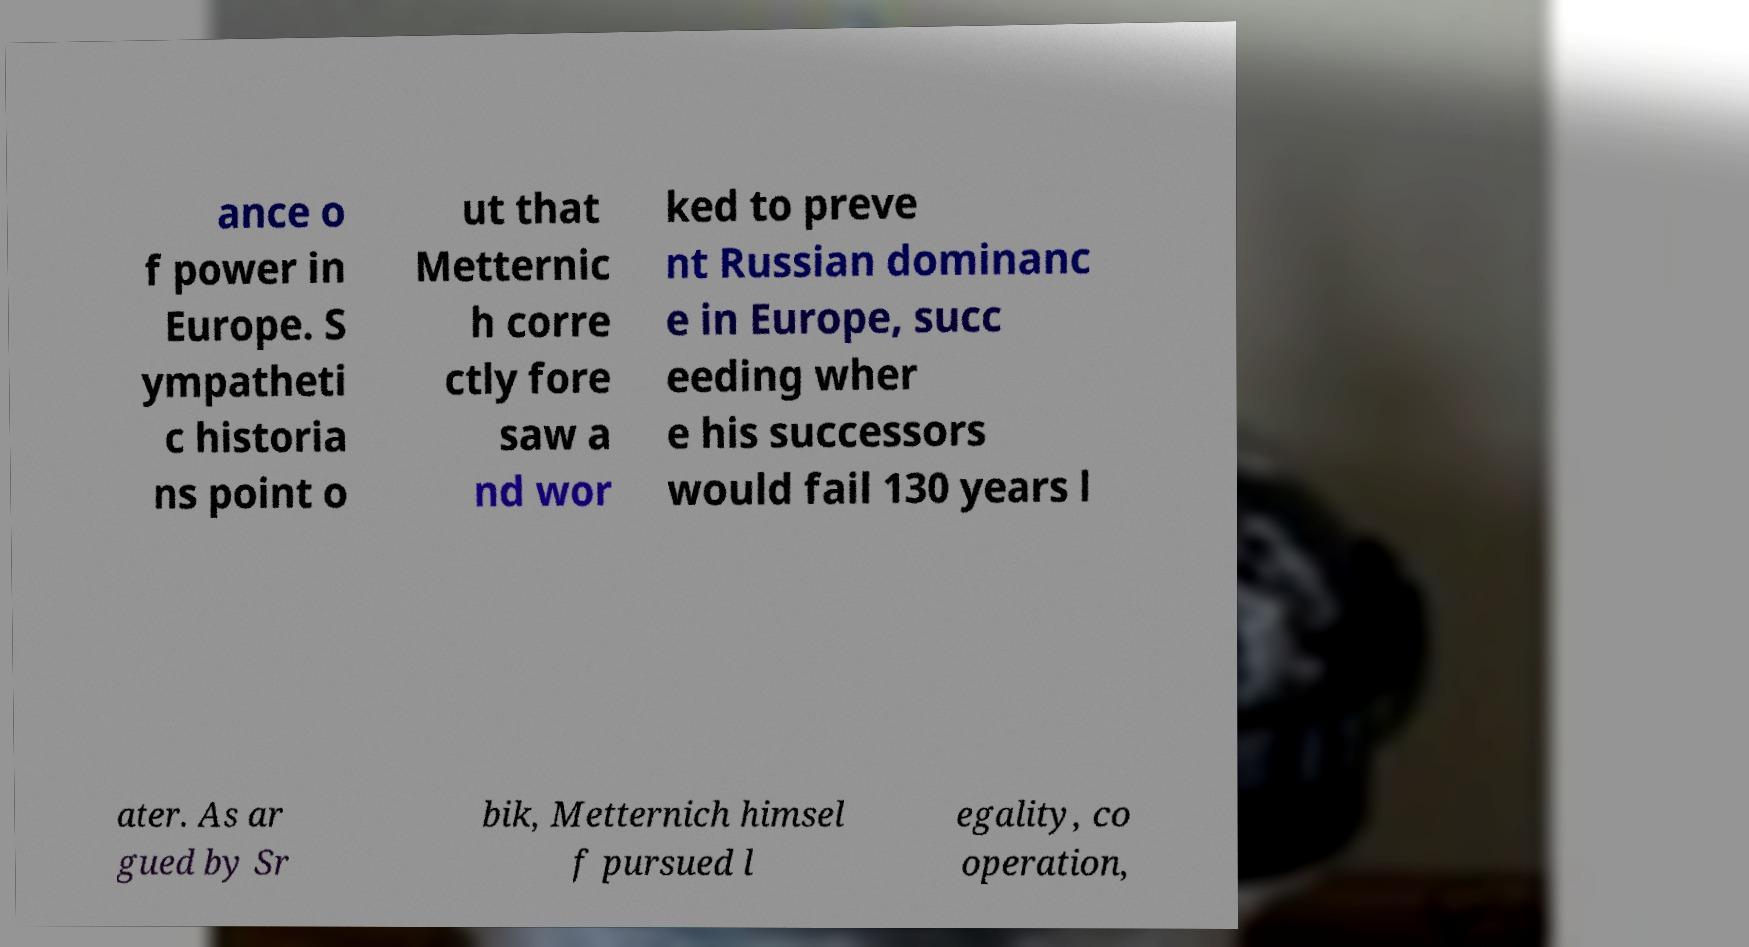There's text embedded in this image that I need extracted. Can you transcribe it verbatim? ance o f power in Europe. S ympatheti c historia ns point o ut that Metternic h corre ctly fore saw a nd wor ked to preve nt Russian dominanc e in Europe, succ eeding wher e his successors would fail 130 years l ater. As ar gued by Sr bik, Metternich himsel f pursued l egality, co operation, 